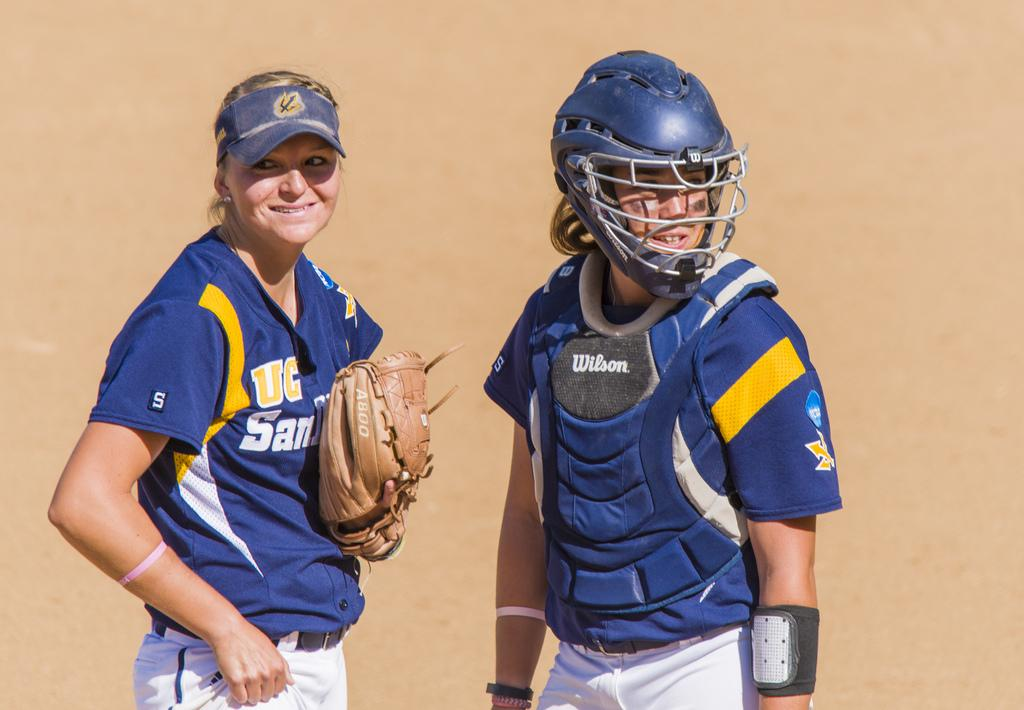<image>
Give a short and clear explanation of the subsequent image. two people are in baseball gear, including a wilson chest protector 